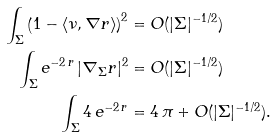Convert formula to latex. <formula><loc_0><loc_0><loc_500><loc_500>\int _ { \Sigma } \left ( 1 - \langle \nu , \nabla r \rangle \right ) ^ { 2 } & = O ( | \Sigma | ^ { - 1 / 2 } ) \\ \int _ { \Sigma } e ^ { - 2 \, r } \, | \nabla _ { \Sigma } r | ^ { 2 } & = O ( | \Sigma | ^ { - 1 / 2 } ) \\ \int _ { \Sigma } 4 \, e ^ { - 2 \, r } & = 4 \, \pi + O ( | \Sigma | ^ { - 1 / 2 } ) .</formula> 